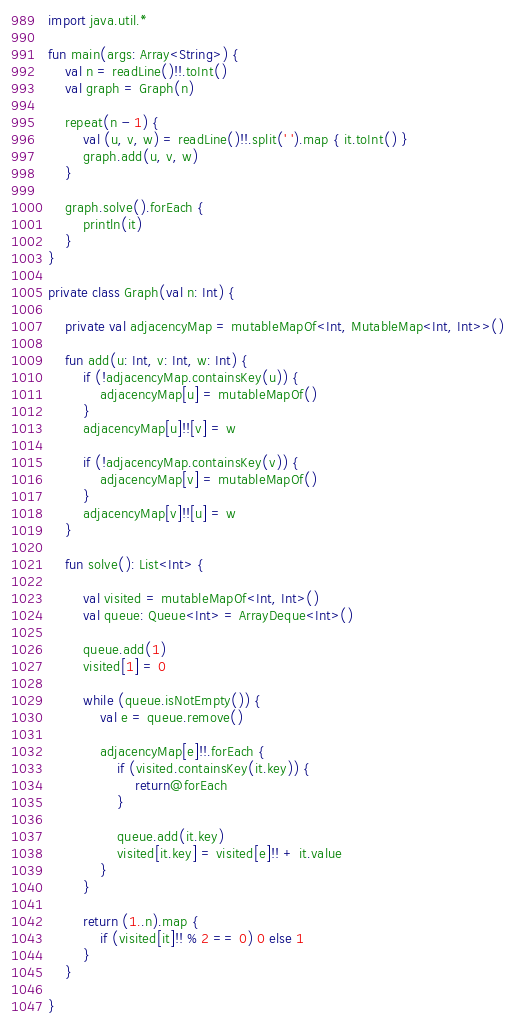<code> <loc_0><loc_0><loc_500><loc_500><_Kotlin_>import java.util.*

fun main(args: Array<String>) {
    val n = readLine()!!.toInt()
    val graph = Graph(n)

    repeat(n - 1) {
        val (u, v, w) = readLine()!!.split(' ').map { it.toInt() }
        graph.add(u, v, w)
    }

    graph.solve().forEach {
        println(it)
    }
}

private class Graph(val n: Int) {

    private val adjacencyMap = mutableMapOf<Int, MutableMap<Int, Int>>()

    fun add(u: Int, v: Int, w: Int) {
        if (!adjacencyMap.containsKey(u)) {
            adjacencyMap[u] = mutableMapOf()
        }
        adjacencyMap[u]!![v] = w

        if (!adjacencyMap.containsKey(v)) {
            adjacencyMap[v] = mutableMapOf()
        }
        adjacencyMap[v]!![u] = w
    }

    fun solve(): List<Int> {

        val visited = mutableMapOf<Int, Int>()
        val queue: Queue<Int> = ArrayDeque<Int>()

        queue.add(1)
        visited[1] = 0

        while (queue.isNotEmpty()) {
            val e = queue.remove()

            adjacencyMap[e]!!.forEach {
                if (visited.containsKey(it.key)) {
                    return@forEach
                }

                queue.add(it.key)
                visited[it.key] = visited[e]!! + it.value
            }
        }

        return (1..n).map {
            if (visited[it]!! % 2 == 0) 0 else 1
        }
    }

}</code> 